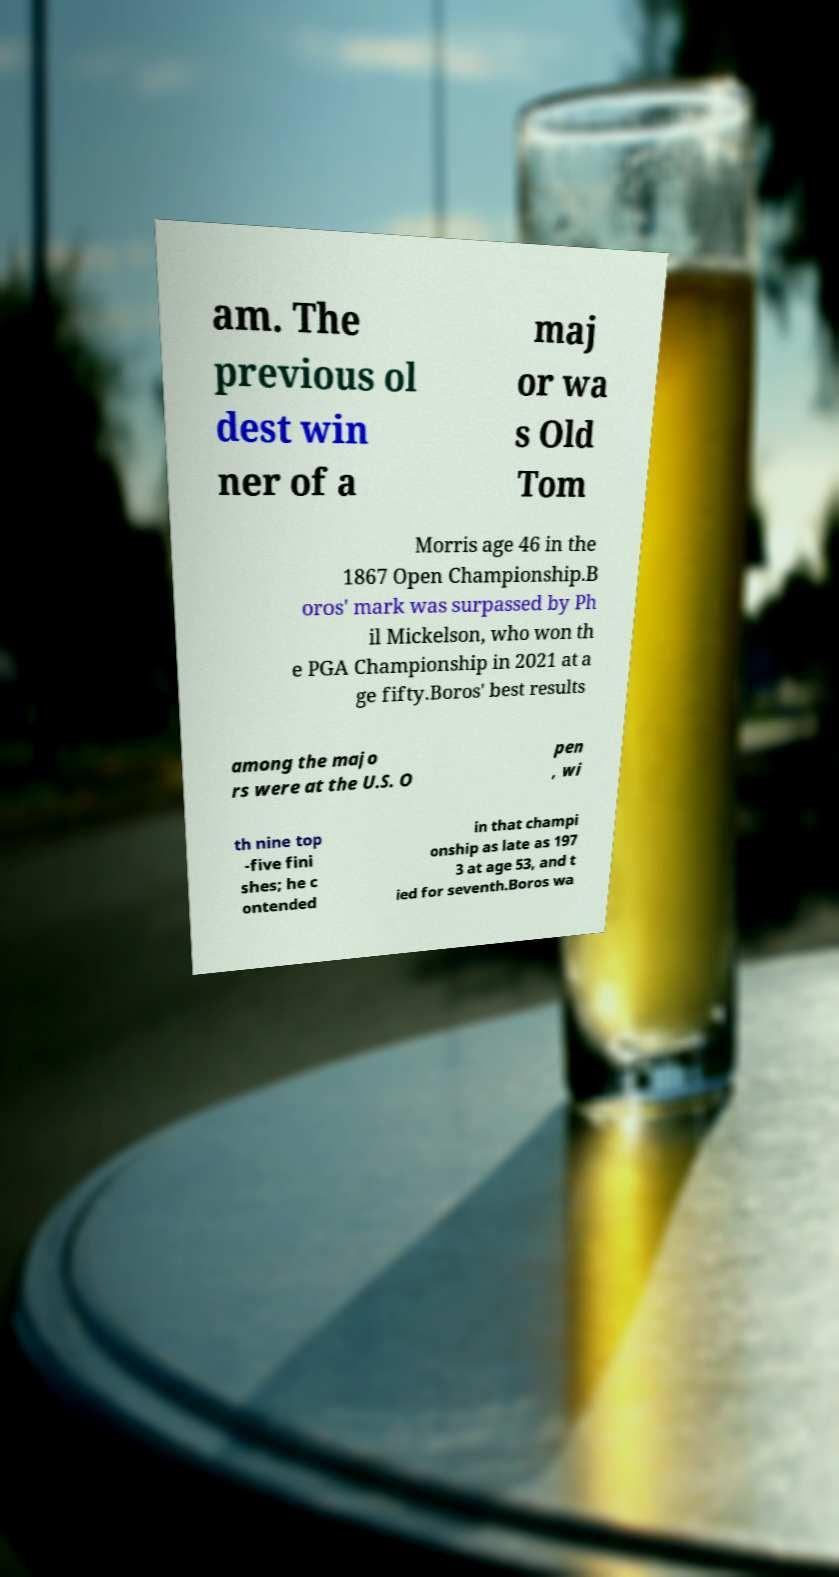What messages or text are displayed in this image? I need them in a readable, typed format. am. The previous ol dest win ner of a maj or wa s Old Tom Morris age 46 in the 1867 Open Championship.B oros' mark was surpassed by Ph il Mickelson, who won th e PGA Championship in 2021 at a ge fifty.Boros' best results among the majo rs were at the U.S. O pen , wi th nine top -five fini shes; he c ontended in that champi onship as late as 197 3 at age 53, and t ied for seventh.Boros wa 